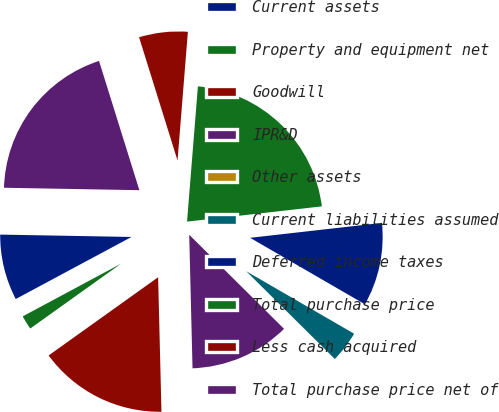Convert chart to OTSL. <chart><loc_0><loc_0><loc_500><loc_500><pie_chart><fcel>Current assets<fcel>Property and equipment net<fcel>Goodwill<fcel>IPR&D<fcel>Other assets<fcel>Current liabilities assumed<fcel>Deferred income taxes<fcel>Total purchase price<fcel>Less cash acquired<fcel>Total purchase price net of<nl><fcel>8.12%<fcel>2.04%<fcel>15.52%<fcel>12.17%<fcel>0.01%<fcel>4.07%<fcel>10.15%<fcel>21.93%<fcel>6.09%<fcel>19.9%<nl></chart> 